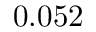Convert formula to latex. <formula><loc_0><loc_0><loc_500><loc_500>0 . 0 5 2</formula> 